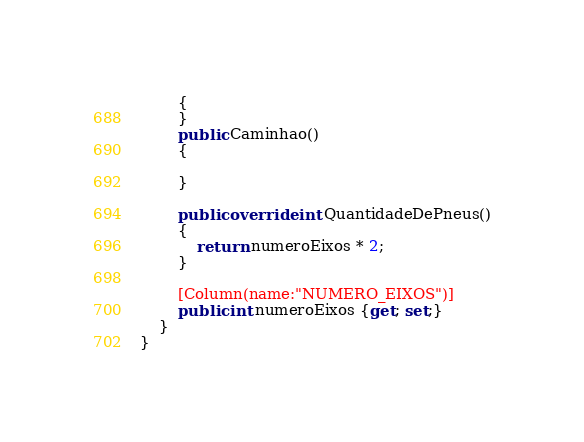Convert code to text. <code><loc_0><loc_0><loc_500><loc_500><_C#_>        {
        }
        public Caminhao() 
        {

        }
        
        public override int QuantidadeDePneus()
        {
            return numeroEixos * 2;
        }
        
        [Column(name:"NUMERO_EIXOS")]
        public int numeroEixos {get; set;}
    }
}</code> 